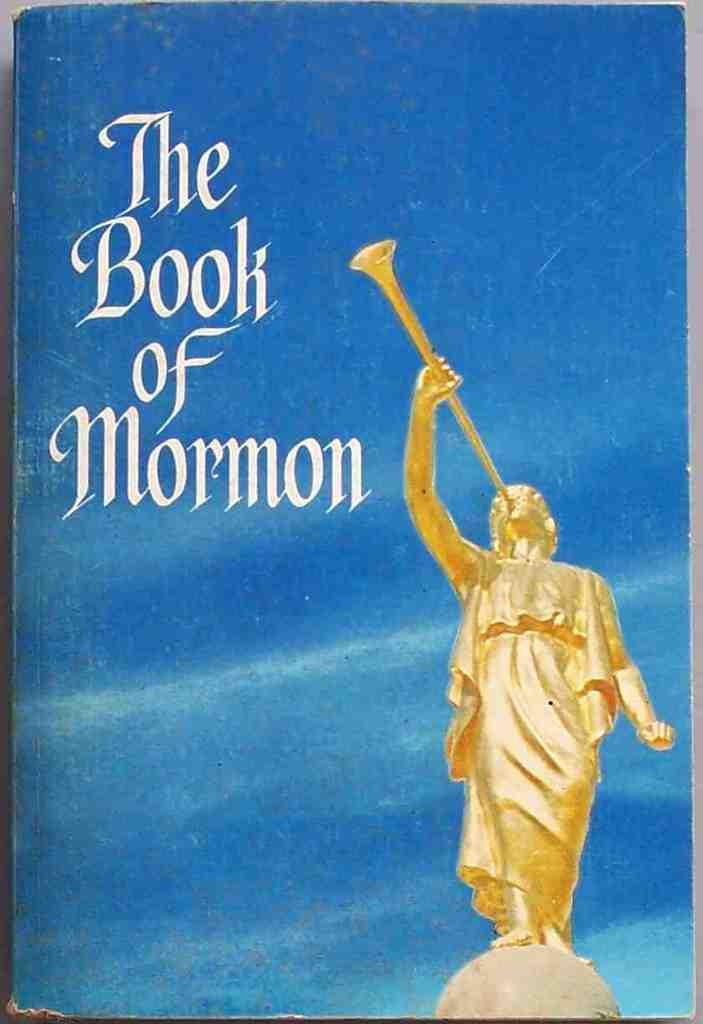<image>
Create a compact narrative representing the image presented. cover of the book titled the book of mormon ith a statue playing a trumpet. 